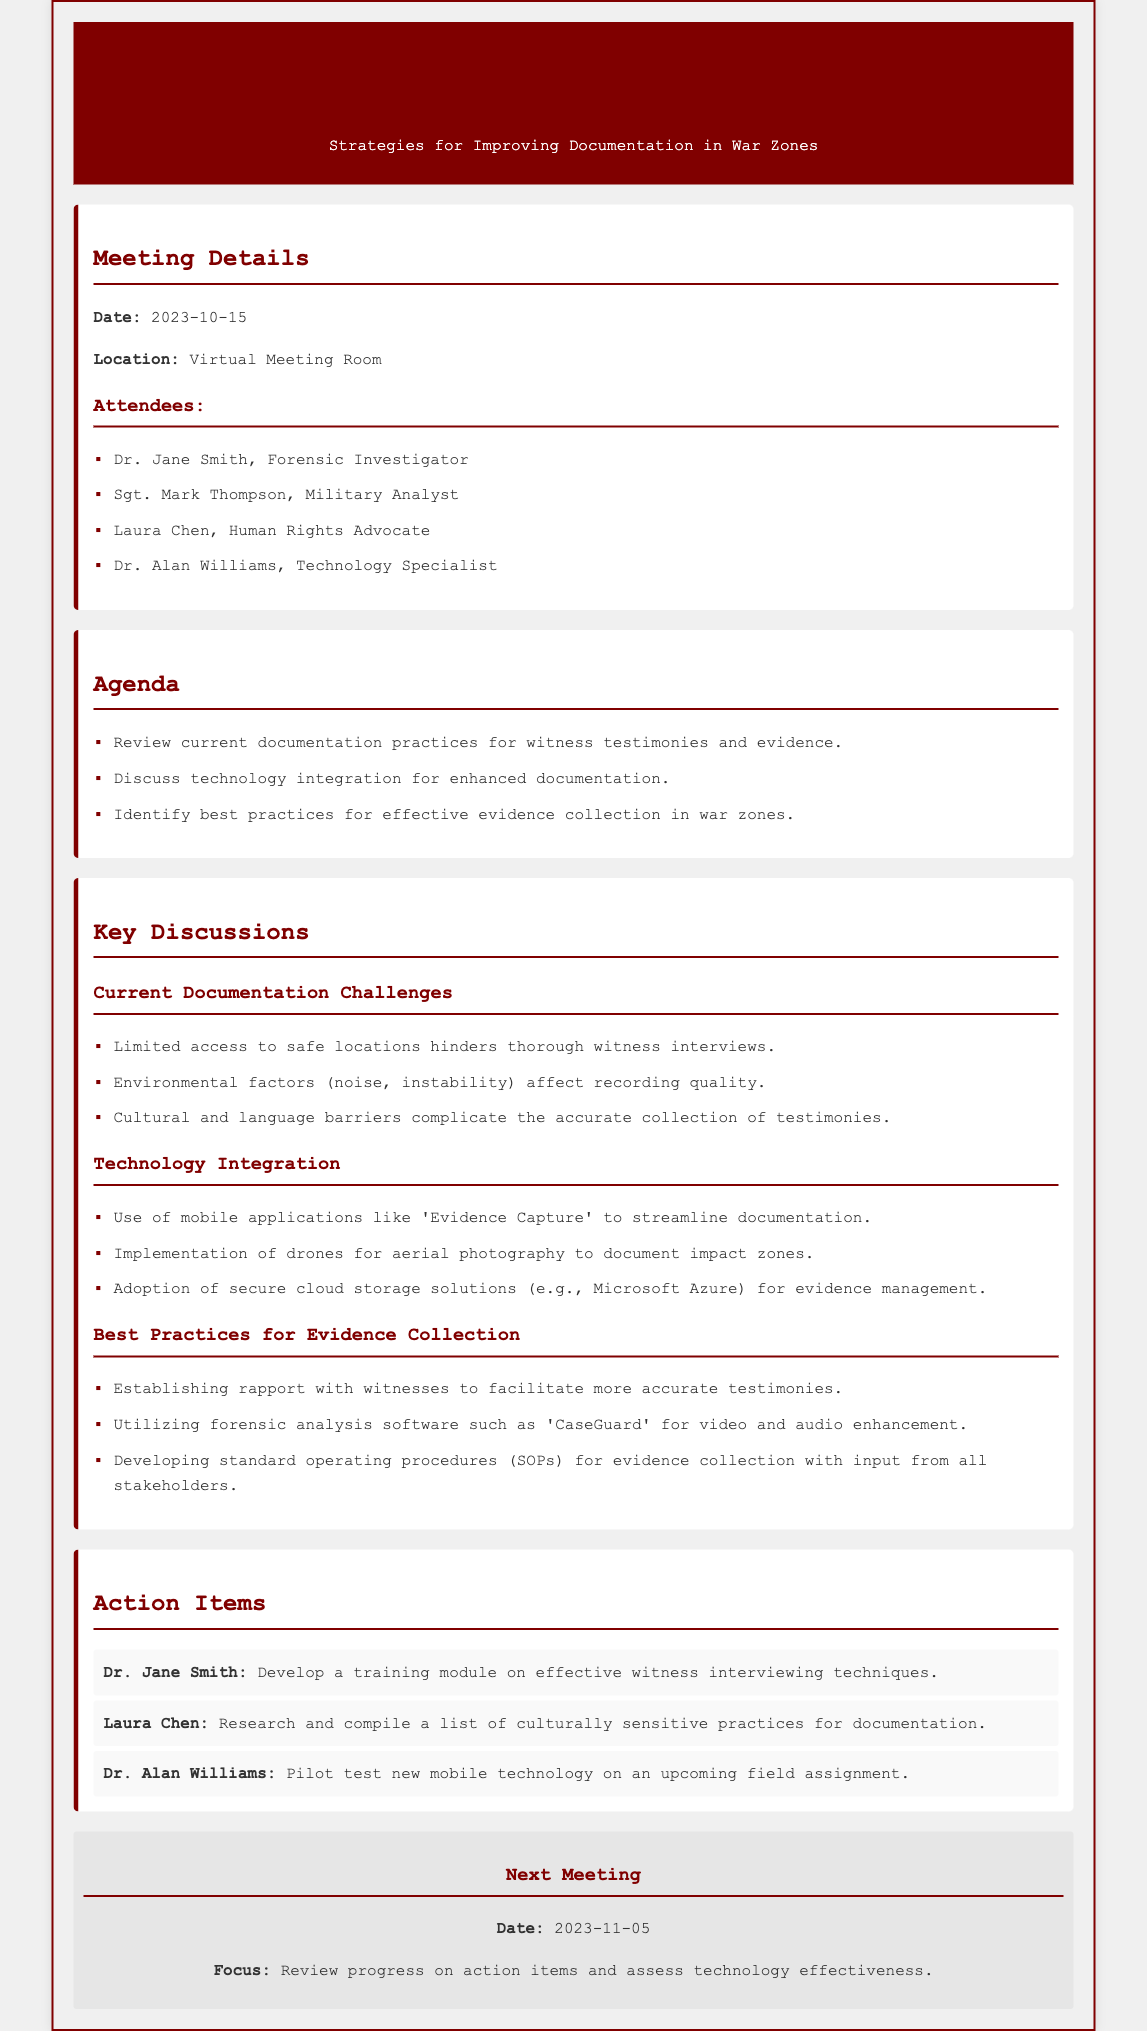what is the date of the meeting? The date of the meeting is mentioned in the document under Meeting Details.
Answer: 2023-10-15 who is responsible for developing a training module on effective witness interviewing techniques? The action items section lists Dr. Jane Smith as the person responsible for this task.
Answer: Dr. Jane Smith what is one technology mentioned for documenting evidence? The document includes a section on Technology Integration, which lists various technologies used for documentation.
Answer: Evidence Capture what is the next meeting date? The document specifies the date of the next meeting in the Next Meeting section.
Answer: 2023-11-05 which attendee is a Technology Specialist? The list of attendees includes their titles, from which the Technology Specialist can be identified.
Answer: Dr. Alan Williams what is a challenge mentioned regarding current documentation practices? Current Documentation Challenges are outlined in the document, reflecting issues faced in the field.
Answer: Limited access to safe locations what is one best practice for evidence collection discussed? The document outlines several best practices for effective evidence collection in war zones.
Answer: Establishing rapport with witnesses who is tasked with researching culturally sensitive practices for documentation? The action items indicate who has taken on the task of researching this area.
Answer: Laura Chen what technology is suggested for aerial photography? Technology Integration discusses the use of various tools, including one for aerial photography.
Answer: Drones 